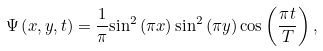<formula> <loc_0><loc_0><loc_500><loc_500>\Psi \left ( x , y , t \right ) = \frac { 1 } { \pi } { \sin } ^ { 2 } \left ( \pi { x } \right ) { \sin } ^ { 2 } \left ( \pi { y } \right ) { \cos } \left ( \frac { \pi { t } } { T } \right ) ,</formula> 